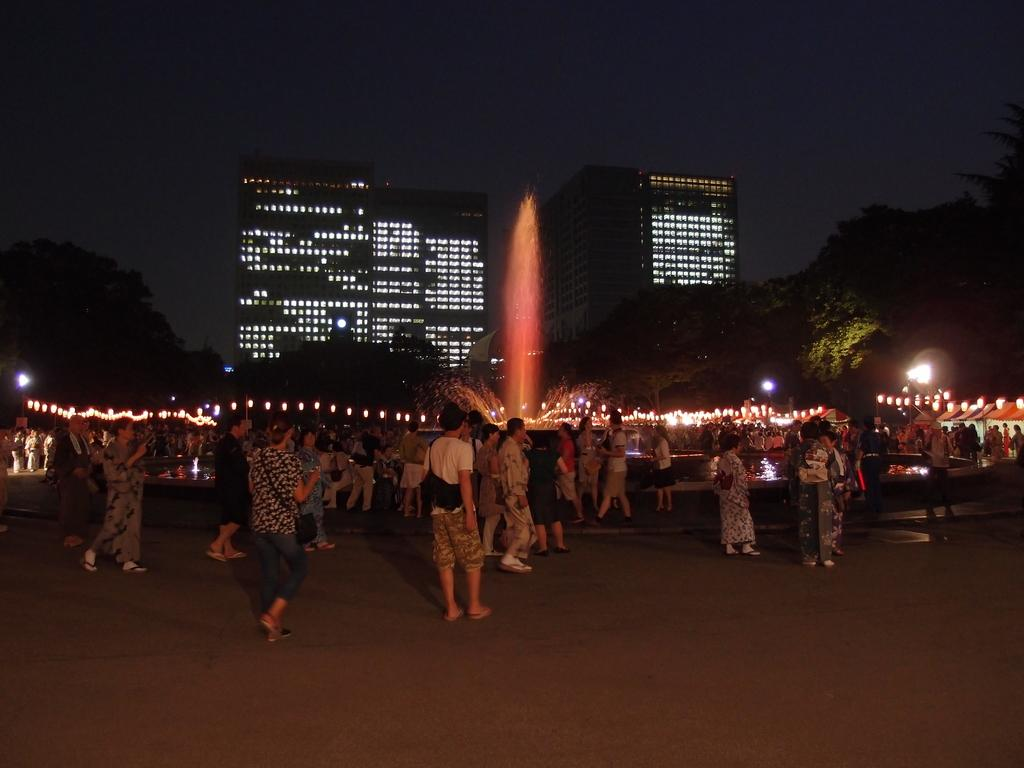What can be seen in the image in terms of human presence? There are people standing in the image. What type of structures are visible in the image? There are buildings in the image. What illuminates the scene in the image? There are lights in the image. What are the vertical structures in the image used for? There are poles in the image, which are likely used for supporting lights or other fixtures. What type of vegetation is present in the image? There are trees in the image. What type of water feature can be seen in the image? There is a water fountain in the image. What type of twig is being used to heal the wound in the image? There is no twig or wound present in the image. What type of trains can be seen passing by in the image? There are no trains present in the image. 